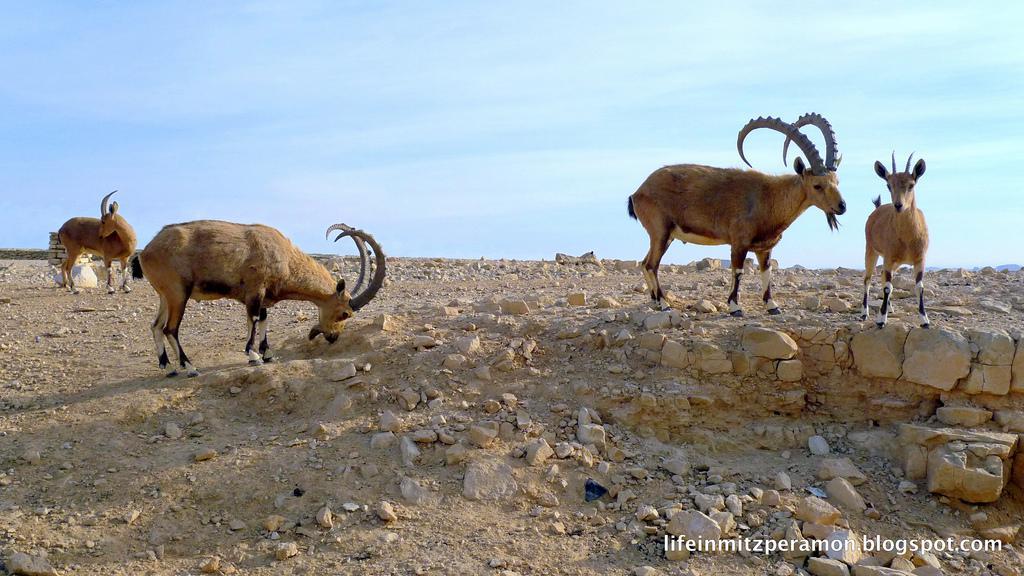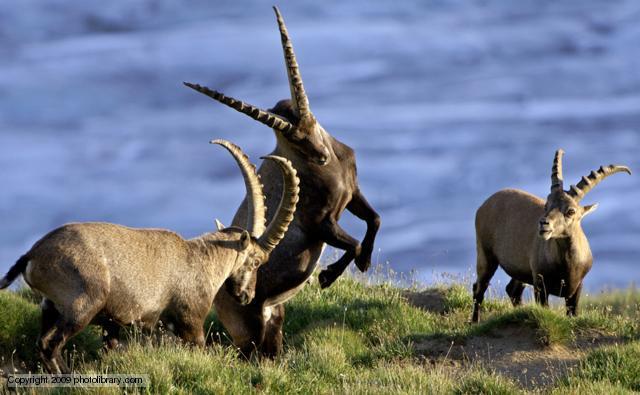The first image is the image on the left, the second image is the image on the right. Examine the images to the left and right. Is the description "Three horned animals are in a grassy area in the image on the right." accurate? Answer yes or no. Yes. The first image is the image on the left, the second image is the image on the right. Assess this claim about the two images: "An image includes a rearing horned animal with front legs raised, facing off with another horned animal.". Correct or not? Answer yes or no. Yes. 